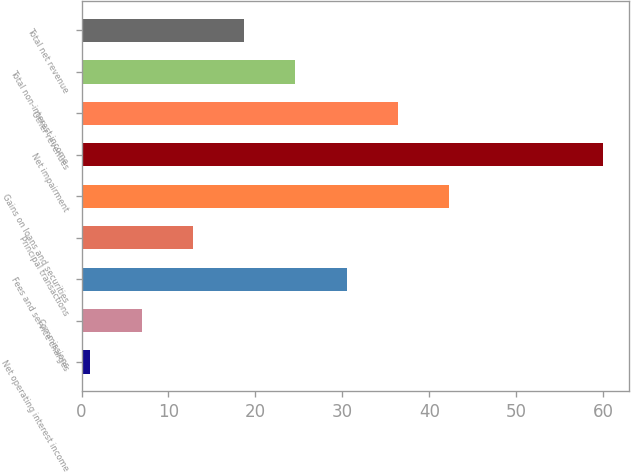Convert chart to OTSL. <chart><loc_0><loc_0><loc_500><loc_500><bar_chart><fcel>Net operating interest income<fcel>Commissions<fcel>Fees and service charges<fcel>Principal transactions<fcel>Gains on loans and securities<fcel>Net impairment<fcel>Other revenues<fcel>Total non-interest income<fcel>Total net revenue<nl><fcel>1<fcel>6.9<fcel>30.5<fcel>12.8<fcel>42.3<fcel>60<fcel>36.4<fcel>24.6<fcel>18.7<nl></chart> 